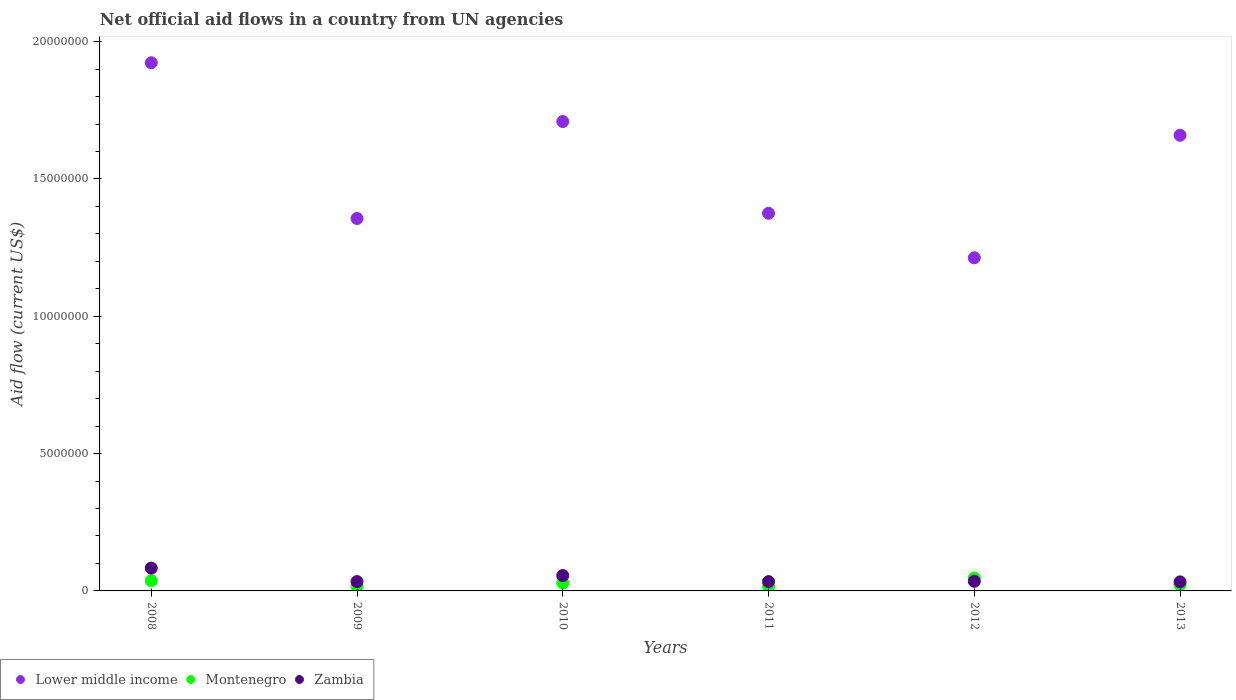Is the number of dotlines equal to the number of legend labels?
Offer a terse response. Yes. What is the net official aid flow in Lower middle income in 2008?
Provide a succinct answer. 1.92e+07. Across all years, what is the maximum net official aid flow in Montenegro?
Your response must be concise. 4.70e+05. Across all years, what is the minimum net official aid flow in Lower middle income?
Your answer should be very brief. 1.21e+07. What is the total net official aid flow in Lower middle income in the graph?
Your answer should be compact. 9.24e+07. What is the difference between the net official aid flow in Montenegro in 2011 and that in 2013?
Your answer should be compact. -6.00e+04. What is the difference between the net official aid flow in Lower middle income in 2012 and the net official aid flow in Zambia in 2009?
Your response must be concise. 1.18e+07. What is the average net official aid flow in Lower middle income per year?
Ensure brevity in your answer.  1.54e+07. In the year 2010, what is the difference between the net official aid flow in Lower middle income and net official aid flow in Montenegro?
Your answer should be compact. 1.68e+07. In how many years, is the net official aid flow in Lower middle income greater than 18000000 US$?
Provide a short and direct response. 1. What is the ratio of the net official aid flow in Zambia in 2008 to that in 2010?
Offer a very short reply. 1.48. Is the net official aid flow in Montenegro in 2008 less than that in 2009?
Offer a very short reply. No. What is the difference between the highest and the second highest net official aid flow in Zambia?
Your response must be concise. 2.70e+05. What is the difference between the highest and the lowest net official aid flow in Montenegro?
Keep it short and to the point. 3.10e+05. In how many years, is the net official aid flow in Montenegro greater than the average net official aid flow in Montenegro taken over all years?
Your answer should be compact. 3. Is the net official aid flow in Lower middle income strictly less than the net official aid flow in Montenegro over the years?
Keep it short and to the point. No. How many dotlines are there?
Provide a succinct answer. 3. How many years are there in the graph?
Offer a terse response. 6. What is the difference between two consecutive major ticks on the Y-axis?
Make the answer very short. 5.00e+06. Are the values on the major ticks of Y-axis written in scientific E-notation?
Offer a terse response. No. Where does the legend appear in the graph?
Offer a terse response. Bottom left. How are the legend labels stacked?
Offer a terse response. Horizontal. What is the title of the graph?
Provide a short and direct response. Net official aid flows in a country from UN agencies. What is the label or title of the Y-axis?
Keep it short and to the point. Aid flow (current US$). What is the Aid flow (current US$) of Lower middle income in 2008?
Provide a short and direct response. 1.92e+07. What is the Aid flow (current US$) of Montenegro in 2008?
Give a very brief answer. 3.70e+05. What is the Aid flow (current US$) in Zambia in 2008?
Offer a terse response. 8.30e+05. What is the Aid flow (current US$) in Lower middle income in 2009?
Provide a succinct answer. 1.36e+07. What is the Aid flow (current US$) in Zambia in 2009?
Keep it short and to the point. 3.40e+05. What is the Aid flow (current US$) of Lower middle income in 2010?
Give a very brief answer. 1.71e+07. What is the Aid flow (current US$) in Zambia in 2010?
Your response must be concise. 5.60e+05. What is the Aid flow (current US$) of Lower middle income in 2011?
Ensure brevity in your answer.  1.38e+07. What is the Aid flow (current US$) of Lower middle income in 2012?
Make the answer very short. 1.21e+07. What is the Aid flow (current US$) in Lower middle income in 2013?
Provide a short and direct response. 1.66e+07. What is the Aid flow (current US$) of Montenegro in 2013?
Your answer should be very brief. 2.20e+05. Across all years, what is the maximum Aid flow (current US$) of Lower middle income?
Your answer should be very brief. 1.92e+07. Across all years, what is the maximum Aid flow (current US$) of Montenegro?
Offer a terse response. 4.70e+05. Across all years, what is the maximum Aid flow (current US$) in Zambia?
Provide a succinct answer. 8.30e+05. Across all years, what is the minimum Aid flow (current US$) of Lower middle income?
Offer a terse response. 1.21e+07. Across all years, what is the minimum Aid flow (current US$) in Montenegro?
Your answer should be compact. 1.60e+05. Across all years, what is the minimum Aid flow (current US$) in Zambia?
Provide a succinct answer. 3.30e+05. What is the total Aid flow (current US$) of Lower middle income in the graph?
Your answer should be very brief. 9.24e+07. What is the total Aid flow (current US$) of Montenegro in the graph?
Your answer should be very brief. 1.68e+06. What is the total Aid flow (current US$) of Zambia in the graph?
Your response must be concise. 2.75e+06. What is the difference between the Aid flow (current US$) of Lower middle income in 2008 and that in 2009?
Make the answer very short. 5.67e+06. What is the difference between the Aid flow (current US$) of Montenegro in 2008 and that in 2009?
Provide a short and direct response. 2.00e+05. What is the difference between the Aid flow (current US$) in Lower middle income in 2008 and that in 2010?
Offer a terse response. 2.14e+06. What is the difference between the Aid flow (current US$) in Montenegro in 2008 and that in 2010?
Your answer should be compact. 8.00e+04. What is the difference between the Aid flow (current US$) of Lower middle income in 2008 and that in 2011?
Give a very brief answer. 5.48e+06. What is the difference between the Aid flow (current US$) in Montenegro in 2008 and that in 2011?
Offer a very short reply. 2.10e+05. What is the difference between the Aid flow (current US$) in Lower middle income in 2008 and that in 2012?
Provide a succinct answer. 7.10e+06. What is the difference between the Aid flow (current US$) of Zambia in 2008 and that in 2012?
Your answer should be very brief. 4.80e+05. What is the difference between the Aid flow (current US$) of Lower middle income in 2008 and that in 2013?
Provide a succinct answer. 2.64e+06. What is the difference between the Aid flow (current US$) in Lower middle income in 2009 and that in 2010?
Your answer should be very brief. -3.53e+06. What is the difference between the Aid flow (current US$) of Montenegro in 2009 and that in 2011?
Provide a succinct answer. 10000. What is the difference between the Aid flow (current US$) of Lower middle income in 2009 and that in 2012?
Provide a short and direct response. 1.43e+06. What is the difference between the Aid flow (current US$) in Lower middle income in 2009 and that in 2013?
Your answer should be very brief. -3.03e+06. What is the difference between the Aid flow (current US$) of Montenegro in 2009 and that in 2013?
Offer a very short reply. -5.00e+04. What is the difference between the Aid flow (current US$) in Lower middle income in 2010 and that in 2011?
Make the answer very short. 3.34e+06. What is the difference between the Aid flow (current US$) of Zambia in 2010 and that in 2011?
Offer a terse response. 2.20e+05. What is the difference between the Aid flow (current US$) of Lower middle income in 2010 and that in 2012?
Make the answer very short. 4.96e+06. What is the difference between the Aid flow (current US$) of Montenegro in 2010 and that in 2013?
Your answer should be very brief. 7.00e+04. What is the difference between the Aid flow (current US$) in Lower middle income in 2011 and that in 2012?
Your answer should be very brief. 1.62e+06. What is the difference between the Aid flow (current US$) in Montenegro in 2011 and that in 2012?
Offer a very short reply. -3.10e+05. What is the difference between the Aid flow (current US$) of Zambia in 2011 and that in 2012?
Your answer should be compact. -10000. What is the difference between the Aid flow (current US$) in Lower middle income in 2011 and that in 2013?
Offer a very short reply. -2.84e+06. What is the difference between the Aid flow (current US$) of Zambia in 2011 and that in 2013?
Ensure brevity in your answer.  10000. What is the difference between the Aid flow (current US$) in Lower middle income in 2012 and that in 2013?
Provide a succinct answer. -4.46e+06. What is the difference between the Aid flow (current US$) of Montenegro in 2012 and that in 2013?
Provide a succinct answer. 2.50e+05. What is the difference between the Aid flow (current US$) of Zambia in 2012 and that in 2013?
Provide a short and direct response. 2.00e+04. What is the difference between the Aid flow (current US$) in Lower middle income in 2008 and the Aid flow (current US$) in Montenegro in 2009?
Offer a terse response. 1.91e+07. What is the difference between the Aid flow (current US$) of Lower middle income in 2008 and the Aid flow (current US$) of Zambia in 2009?
Offer a very short reply. 1.89e+07. What is the difference between the Aid flow (current US$) in Lower middle income in 2008 and the Aid flow (current US$) in Montenegro in 2010?
Provide a succinct answer. 1.89e+07. What is the difference between the Aid flow (current US$) of Lower middle income in 2008 and the Aid flow (current US$) of Zambia in 2010?
Your answer should be very brief. 1.87e+07. What is the difference between the Aid flow (current US$) in Montenegro in 2008 and the Aid flow (current US$) in Zambia in 2010?
Keep it short and to the point. -1.90e+05. What is the difference between the Aid flow (current US$) in Lower middle income in 2008 and the Aid flow (current US$) in Montenegro in 2011?
Your response must be concise. 1.91e+07. What is the difference between the Aid flow (current US$) of Lower middle income in 2008 and the Aid flow (current US$) of Zambia in 2011?
Keep it short and to the point. 1.89e+07. What is the difference between the Aid flow (current US$) in Montenegro in 2008 and the Aid flow (current US$) in Zambia in 2011?
Give a very brief answer. 3.00e+04. What is the difference between the Aid flow (current US$) of Lower middle income in 2008 and the Aid flow (current US$) of Montenegro in 2012?
Your answer should be very brief. 1.88e+07. What is the difference between the Aid flow (current US$) of Lower middle income in 2008 and the Aid flow (current US$) of Zambia in 2012?
Offer a terse response. 1.89e+07. What is the difference between the Aid flow (current US$) in Montenegro in 2008 and the Aid flow (current US$) in Zambia in 2012?
Offer a very short reply. 2.00e+04. What is the difference between the Aid flow (current US$) in Lower middle income in 2008 and the Aid flow (current US$) in Montenegro in 2013?
Make the answer very short. 1.90e+07. What is the difference between the Aid flow (current US$) in Lower middle income in 2008 and the Aid flow (current US$) in Zambia in 2013?
Give a very brief answer. 1.89e+07. What is the difference between the Aid flow (current US$) of Montenegro in 2008 and the Aid flow (current US$) of Zambia in 2013?
Make the answer very short. 4.00e+04. What is the difference between the Aid flow (current US$) of Lower middle income in 2009 and the Aid flow (current US$) of Montenegro in 2010?
Your response must be concise. 1.33e+07. What is the difference between the Aid flow (current US$) of Lower middle income in 2009 and the Aid flow (current US$) of Zambia in 2010?
Your response must be concise. 1.30e+07. What is the difference between the Aid flow (current US$) in Montenegro in 2009 and the Aid flow (current US$) in Zambia in 2010?
Keep it short and to the point. -3.90e+05. What is the difference between the Aid flow (current US$) in Lower middle income in 2009 and the Aid flow (current US$) in Montenegro in 2011?
Provide a succinct answer. 1.34e+07. What is the difference between the Aid flow (current US$) of Lower middle income in 2009 and the Aid flow (current US$) of Zambia in 2011?
Provide a succinct answer. 1.32e+07. What is the difference between the Aid flow (current US$) of Montenegro in 2009 and the Aid flow (current US$) of Zambia in 2011?
Your answer should be very brief. -1.70e+05. What is the difference between the Aid flow (current US$) of Lower middle income in 2009 and the Aid flow (current US$) of Montenegro in 2012?
Provide a succinct answer. 1.31e+07. What is the difference between the Aid flow (current US$) in Lower middle income in 2009 and the Aid flow (current US$) in Zambia in 2012?
Provide a succinct answer. 1.32e+07. What is the difference between the Aid flow (current US$) of Lower middle income in 2009 and the Aid flow (current US$) of Montenegro in 2013?
Ensure brevity in your answer.  1.33e+07. What is the difference between the Aid flow (current US$) in Lower middle income in 2009 and the Aid flow (current US$) in Zambia in 2013?
Provide a succinct answer. 1.32e+07. What is the difference between the Aid flow (current US$) of Lower middle income in 2010 and the Aid flow (current US$) of Montenegro in 2011?
Your answer should be very brief. 1.69e+07. What is the difference between the Aid flow (current US$) of Lower middle income in 2010 and the Aid flow (current US$) of Zambia in 2011?
Your answer should be very brief. 1.68e+07. What is the difference between the Aid flow (current US$) in Montenegro in 2010 and the Aid flow (current US$) in Zambia in 2011?
Your answer should be compact. -5.00e+04. What is the difference between the Aid flow (current US$) in Lower middle income in 2010 and the Aid flow (current US$) in Montenegro in 2012?
Offer a very short reply. 1.66e+07. What is the difference between the Aid flow (current US$) in Lower middle income in 2010 and the Aid flow (current US$) in Zambia in 2012?
Give a very brief answer. 1.67e+07. What is the difference between the Aid flow (current US$) in Lower middle income in 2010 and the Aid flow (current US$) in Montenegro in 2013?
Ensure brevity in your answer.  1.69e+07. What is the difference between the Aid flow (current US$) in Lower middle income in 2010 and the Aid flow (current US$) in Zambia in 2013?
Provide a short and direct response. 1.68e+07. What is the difference between the Aid flow (current US$) of Montenegro in 2010 and the Aid flow (current US$) of Zambia in 2013?
Keep it short and to the point. -4.00e+04. What is the difference between the Aid flow (current US$) of Lower middle income in 2011 and the Aid flow (current US$) of Montenegro in 2012?
Ensure brevity in your answer.  1.33e+07. What is the difference between the Aid flow (current US$) of Lower middle income in 2011 and the Aid flow (current US$) of Zambia in 2012?
Give a very brief answer. 1.34e+07. What is the difference between the Aid flow (current US$) in Lower middle income in 2011 and the Aid flow (current US$) in Montenegro in 2013?
Your answer should be compact. 1.35e+07. What is the difference between the Aid flow (current US$) of Lower middle income in 2011 and the Aid flow (current US$) of Zambia in 2013?
Your answer should be compact. 1.34e+07. What is the difference between the Aid flow (current US$) of Lower middle income in 2012 and the Aid flow (current US$) of Montenegro in 2013?
Your response must be concise. 1.19e+07. What is the difference between the Aid flow (current US$) in Lower middle income in 2012 and the Aid flow (current US$) in Zambia in 2013?
Keep it short and to the point. 1.18e+07. What is the average Aid flow (current US$) in Lower middle income per year?
Your response must be concise. 1.54e+07. What is the average Aid flow (current US$) in Montenegro per year?
Your response must be concise. 2.80e+05. What is the average Aid flow (current US$) of Zambia per year?
Your response must be concise. 4.58e+05. In the year 2008, what is the difference between the Aid flow (current US$) of Lower middle income and Aid flow (current US$) of Montenegro?
Offer a very short reply. 1.89e+07. In the year 2008, what is the difference between the Aid flow (current US$) in Lower middle income and Aid flow (current US$) in Zambia?
Your response must be concise. 1.84e+07. In the year 2008, what is the difference between the Aid flow (current US$) in Montenegro and Aid flow (current US$) in Zambia?
Give a very brief answer. -4.60e+05. In the year 2009, what is the difference between the Aid flow (current US$) in Lower middle income and Aid flow (current US$) in Montenegro?
Give a very brief answer. 1.34e+07. In the year 2009, what is the difference between the Aid flow (current US$) in Lower middle income and Aid flow (current US$) in Zambia?
Give a very brief answer. 1.32e+07. In the year 2009, what is the difference between the Aid flow (current US$) in Montenegro and Aid flow (current US$) in Zambia?
Your response must be concise. -1.70e+05. In the year 2010, what is the difference between the Aid flow (current US$) in Lower middle income and Aid flow (current US$) in Montenegro?
Ensure brevity in your answer.  1.68e+07. In the year 2010, what is the difference between the Aid flow (current US$) of Lower middle income and Aid flow (current US$) of Zambia?
Offer a terse response. 1.65e+07. In the year 2011, what is the difference between the Aid flow (current US$) in Lower middle income and Aid flow (current US$) in Montenegro?
Keep it short and to the point. 1.36e+07. In the year 2011, what is the difference between the Aid flow (current US$) of Lower middle income and Aid flow (current US$) of Zambia?
Provide a short and direct response. 1.34e+07. In the year 2012, what is the difference between the Aid flow (current US$) of Lower middle income and Aid flow (current US$) of Montenegro?
Offer a terse response. 1.17e+07. In the year 2012, what is the difference between the Aid flow (current US$) in Lower middle income and Aid flow (current US$) in Zambia?
Offer a terse response. 1.18e+07. In the year 2012, what is the difference between the Aid flow (current US$) in Montenegro and Aid flow (current US$) in Zambia?
Ensure brevity in your answer.  1.20e+05. In the year 2013, what is the difference between the Aid flow (current US$) in Lower middle income and Aid flow (current US$) in Montenegro?
Provide a short and direct response. 1.64e+07. In the year 2013, what is the difference between the Aid flow (current US$) of Lower middle income and Aid flow (current US$) of Zambia?
Provide a succinct answer. 1.63e+07. In the year 2013, what is the difference between the Aid flow (current US$) in Montenegro and Aid flow (current US$) in Zambia?
Your answer should be very brief. -1.10e+05. What is the ratio of the Aid flow (current US$) in Lower middle income in 2008 to that in 2009?
Provide a short and direct response. 1.42. What is the ratio of the Aid flow (current US$) in Montenegro in 2008 to that in 2009?
Offer a terse response. 2.18. What is the ratio of the Aid flow (current US$) of Zambia in 2008 to that in 2009?
Offer a very short reply. 2.44. What is the ratio of the Aid flow (current US$) of Lower middle income in 2008 to that in 2010?
Offer a terse response. 1.13. What is the ratio of the Aid flow (current US$) in Montenegro in 2008 to that in 2010?
Keep it short and to the point. 1.28. What is the ratio of the Aid flow (current US$) of Zambia in 2008 to that in 2010?
Offer a very short reply. 1.48. What is the ratio of the Aid flow (current US$) in Lower middle income in 2008 to that in 2011?
Keep it short and to the point. 1.4. What is the ratio of the Aid flow (current US$) of Montenegro in 2008 to that in 2011?
Provide a short and direct response. 2.31. What is the ratio of the Aid flow (current US$) of Zambia in 2008 to that in 2011?
Offer a very short reply. 2.44. What is the ratio of the Aid flow (current US$) in Lower middle income in 2008 to that in 2012?
Ensure brevity in your answer.  1.59. What is the ratio of the Aid flow (current US$) in Montenegro in 2008 to that in 2012?
Make the answer very short. 0.79. What is the ratio of the Aid flow (current US$) of Zambia in 2008 to that in 2012?
Give a very brief answer. 2.37. What is the ratio of the Aid flow (current US$) of Lower middle income in 2008 to that in 2013?
Offer a very short reply. 1.16. What is the ratio of the Aid flow (current US$) in Montenegro in 2008 to that in 2013?
Your response must be concise. 1.68. What is the ratio of the Aid flow (current US$) in Zambia in 2008 to that in 2013?
Make the answer very short. 2.52. What is the ratio of the Aid flow (current US$) in Lower middle income in 2009 to that in 2010?
Give a very brief answer. 0.79. What is the ratio of the Aid flow (current US$) in Montenegro in 2009 to that in 2010?
Make the answer very short. 0.59. What is the ratio of the Aid flow (current US$) in Zambia in 2009 to that in 2010?
Offer a terse response. 0.61. What is the ratio of the Aid flow (current US$) in Lower middle income in 2009 to that in 2011?
Your response must be concise. 0.99. What is the ratio of the Aid flow (current US$) in Montenegro in 2009 to that in 2011?
Your answer should be very brief. 1.06. What is the ratio of the Aid flow (current US$) in Lower middle income in 2009 to that in 2012?
Your answer should be compact. 1.12. What is the ratio of the Aid flow (current US$) in Montenegro in 2009 to that in 2012?
Provide a succinct answer. 0.36. What is the ratio of the Aid flow (current US$) in Zambia in 2009 to that in 2012?
Give a very brief answer. 0.97. What is the ratio of the Aid flow (current US$) in Lower middle income in 2009 to that in 2013?
Provide a succinct answer. 0.82. What is the ratio of the Aid flow (current US$) of Montenegro in 2009 to that in 2013?
Your response must be concise. 0.77. What is the ratio of the Aid flow (current US$) in Zambia in 2009 to that in 2013?
Your response must be concise. 1.03. What is the ratio of the Aid flow (current US$) of Lower middle income in 2010 to that in 2011?
Provide a short and direct response. 1.24. What is the ratio of the Aid flow (current US$) in Montenegro in 2010 to that in 2011?
Your answer should be very brief. 1.81. What is the ratio of the Aid flow (current US$) of Zambia in 2010 to that in 2011?
Ensure brevity in your answer.  1.65. What is the ratio of the Aid flow (current US$) in Lower middle income in 2010 to that in 2012?
Ensure brevity in your answer.  1.41. What is the ratio of the Aid flow (current US$) of Montenegro in 2010 to that in 2012?
Your answer should be compact. 0.62. What is the ratio of the Aid flow (current US$) in Zambia in 2010 to that in 2012?
Keep it short and to the point. 1.6. What is the ratio of the Aid flow (current US$) in Lower middle income in 2010 to that in 2013?
Your response must be concise. 1.03. What is the ratio of the Aid flow (current US$) in Montenegro in 2010 to that in 2013?
Provide a short and direct response. 1.32. What is the ratio of the Aid flow (current US$) in Zambia in 2010 to that in 2013?
Provide a short and direct response. 1.7. What is the ratio of the Aid flow (current US$) of Lower middle income in 2011 to that in 2012?
Provide a short and direct response. 1.13. What is the ratio of the Aid flow (current US$) in Montenegro in 2011 to that in 2012?
Offer a terse response. 0.34. What is the ratio of the Aid flow (current US$) in Zambia in 2011 to that in 2012?
Make the answer very short. 0.97. What is the ratio of the Aid flow (current US$) in Lower middle income in 2011 to that in 2013?
Keep it short and to the point. 0.83. What is the ratio of the Aid flow (current US$) in Montenegro in 2011 to that in 2013?
Your response must be concise. 0.73. What is the ratio of the Aid flow (current US$) in Zambia in 2011 to that in 2013?
Your answer should be very brief. 1.03. What is the ratio of the Aid flow (current US$) in Lower middle income in 2012 to that in 2013?
Your answer should be compact. 0.73. What is the ratio of the Aid flow (current US$) of Montenegro in 2012 to that in 2013?
Provide a short and direct response. 2.14. What is the ratio of the Aid flow (current US$) of Zambia in 2012 to that in 2013?
Your answer should be very brief. 1.06. What is the difference between the highest and the second highest Aid flow (current US$) of Lower middle income?
Ensure brevity in your answer.  2.14e+06. What is the difference between the highest and the lowest Aid flow (current US$) of Lower middle income?
Make the answer very short. 7.10e+06. 